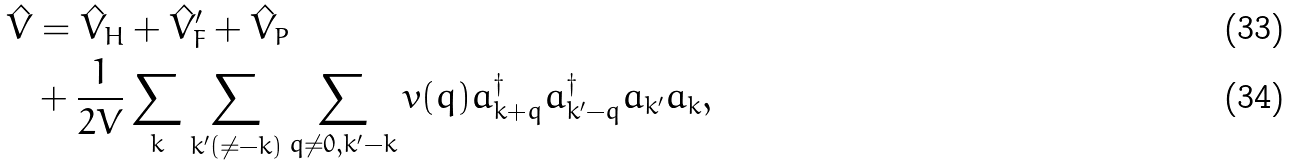Convert formula to latex. <formula><loc_0><loc_0><loc_500><loc_500>\hat { V } & = \hat { V } _ { H } + \hat { V } _ { F } ^ { \prime } + \hat { V } _ { P } \\ & + \frac { 1 } { 2 V } \sum _ { k } \sum _ { k ^ { \prime } ( \neq - k ) } \sum _ { q \neq 0 , { k } ^ { \prime } - { k } } v ( { q } ) a _ { k + q } ^ { \dagger } a _ { k ^ { \prime } - q } ^ { \dagger } a _ { k ^ { \prime } } a _ { k } ,</formula> 